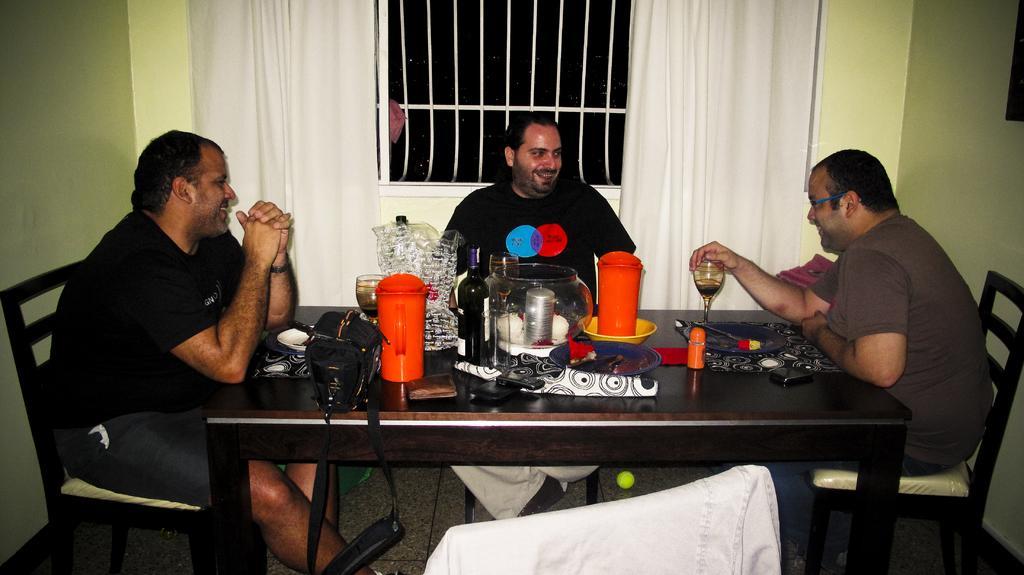In one or two sentences, can you explain what this image depicts? On the background we can see a wall, window, curtains. We can see three men sitting on chairs in front of a table and on the table we can see mugs in orange color, bowl, bottles and drinking glasses, bag. This is a floor. 